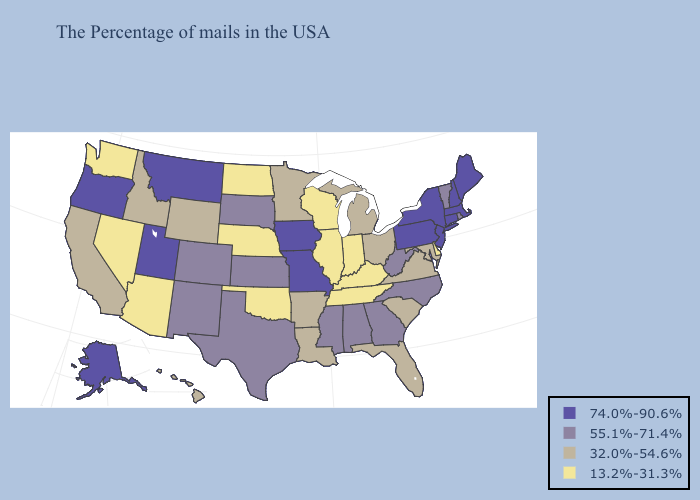Name the states that have a value in the range 13.2%-31.3%?
Concise answer only. Delaware, Kentucky, Indiana, Tennessee, Wisconsin, Illinois, Nebraska, Oklahoma, North Dakota, Arizona, Nevada, Washington. Does New Mexico have the highest value in the USA?
Write a very short answer. No. What is the highest value in the Northeast ?
Keep it brief. 74.0%-90.6%. How many symbols are there in the legend?
Short answer required. 4. What is the value of Connecticut?
Answer briefly. 74.0%-90.6%. What is the highest value in states that border Colorado?
Concise answer only. 74.0%-90.6%. What is the highest value in states that border New Mexico?
Keep it brief. 74.0%-90.6%. Name the states that have a value in the range 74.0%-90.6%?
Keep it brief. Maine, Massachusetts, New Hampshire, Connecticut, New York, New Jersey, Pennsylvania, Missouri, Iowa, Utah, Montana, Oregon, Alaska. What is the value of Kentucky?
Answer briefly. 13.2%-31.3%. Does Utah have a higher value than Alaska?
Write a very short answer. No. What is the highest value in states that border Delaware?
Short answer required. 74.0%-90.6%. Does Wisconsin have the lowest value in the USA?
Answer briefly. Yes. Among the states that border Wyoming , does Utah have the highest value?
Be succinct. Yes. Is the legend a continuous bar?
Be succinct. No. 